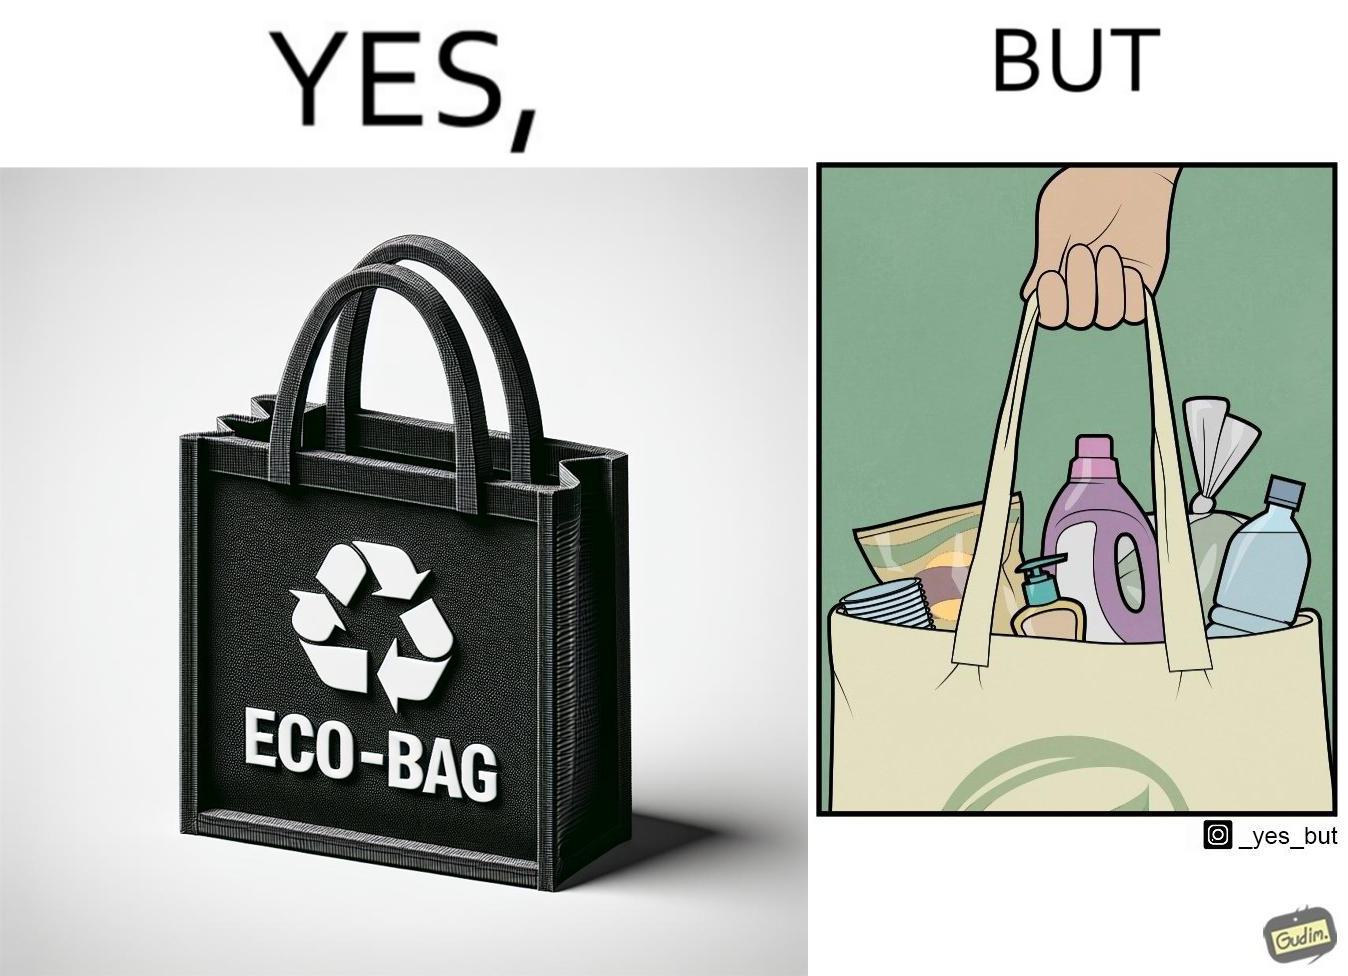Explain the humor or irony in this image. The image is ironic, because people nowadays use eco-bag thinking them as safe for the environment but in turn use products which are harmful for the environment or are packaged in some non-biodegradable material 